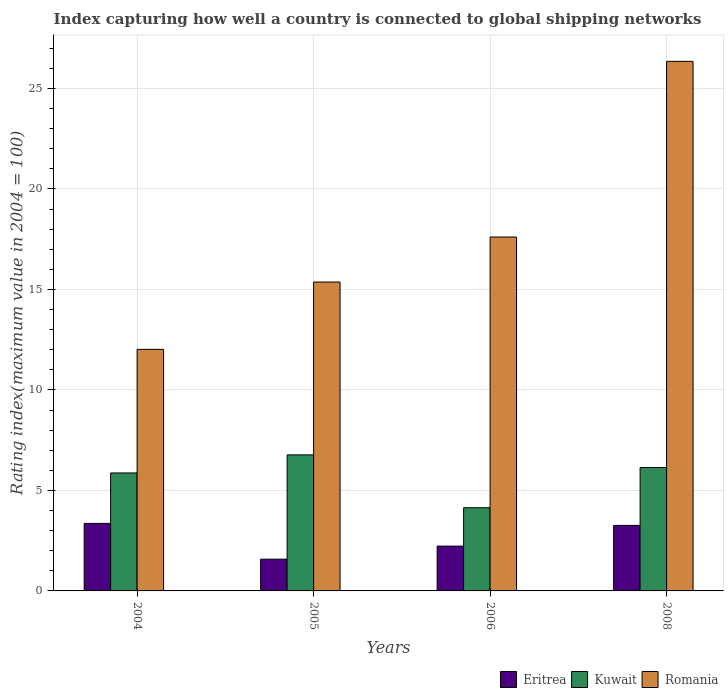How many groups of bars are there?
Provide a succinct answer. 4. Are the number of bars per tick equal to the number of legend labels?
Keep it short and to the point. Yes. How many bars are there on the 4th tick from the left?
Offer a very short reply. 3. What is the label of the 4th group of bars from the left?
Ensure brevity in your answer.  2008. In how many cases, is the number of bars for a given year not equal to the number of legend labels?
Your answer should be compact. 0. What is the rating index in Romania in 2005?
Make the answer very short. 15.37. Across all years, what is the maximum rating index in Romania?
Keep it short and to the point. 26.35. Across all years, what is the minimum rating index in Kuwait?
Offer a terse response. 4.14. What is the total rating index in Romania in the graph?
Keep it short and to the point. 71.35. What is the difference between the rating index in Kuwait in 2006 and that in 2008?
Provide a short and direct response. -2. What is the difference between the rating index in Romania in 2005 and the rating index in Eritrea in 2006?
Ensure brevity in your answer.  13.14. What is the average rating index in Eritrea per year?
Ensure brevity in your answer.  2.61. In the year 2005, what is the difference between the rating index in Kuwait and rating index in Eritrea?
Offer a very short reply. 5.19. In how many years, is the rating index in Kuwait greater than 22?
Provide a succinct answer. 0. What is the ratio of the rating index in Romania in 2004 to that in 2005?
Offer a very short reply. 0.78. Is the difference between the rating index in Kuwait in 2005 and 2008 greater than the difference between the rating index in Eritrea in 2005 and 2008?
Offer a very short reply. Yes. What is the difference between the highest and the second highest rating index in Romania?
Keep it short and to the point. 8.74. What is the difference between the highest and the lowest rating index in Eritrea?
Ensure brevity in your answer.  1.78. What does the 2nd bar from the left in 2006 represents?
Your answer should be compact. Kuwait. What does the 1st bar from the right in 2004 represents?
Provide a succinct answer. Romania. How many bars are there?
Give a very brief answer. 12. How many years are there in the graph?
Provide a short and direct response. 4. What is the difference between two consecutive major ticks on the Y-axis?
Give a very brief answer. 5. Are the values on the major ticks of Y-axis written in scientific E-notation?
Offer a terse response. No. Does the graph contain grids?
Ensure brevity in your answer.  Yes. Where does the legend appear in the graph?
Give a very brief answer. Bottom right. What is the title of the graph?
Your answer should be very brief. Index capturing how well a country is connected to global shipping networks. Does "Small states" appear as one of the legend labels in the graph?
Offer a very short reply. No. What is the label or title of the X-axis?
Provide a succinct answer. Years. What is the label or title of the Y-axis?
Your answer should be very brief. Rating index(maximum value in 2004 = 100). What is the Rating index(maximum value in 2004 = 100) of Eritrea in 2004?
Provide a short and direct response. 3.36. What is the Rating index(maximum value in 2004 = 100) in Kuwait in 2004?
Provide a succinct answer. 5.87. What is the Rating index(maximum value in 2004 = 100) of Romania in 2004?
Provide a short and direct response. 12.02. What is the Rating index(maximum value in 2004 = 100) in Eritrea in 2005?
Offer a terse response. 1.58. What is the Rating index(maximum value in 2004 = 100) in Kuwait in 2005?
Provide a succinct answer. 6.77. What is the Rating index(maximum value in 2004 = 100) in Romania in 2005?
Your response must be concise. 15.37. What is the Rating index(maximum value in 2004 = 100) of Eritrea in 2006?
Your response must be concise. 2.23. What is the Rating index(maximum value in 2004 = 100) in Kuwait in 2006?
Offer a terse response. 4.14. What is the Rating index(maximum value in 2004 = 100) of Romania in 2006?
Make the answer very short. 17.61. What is the Rating index(maximum value in 2004 = 100) of Eritrea in 2008?
Your response must be concise. 3.26. What is the Rating index(maximum value in 2004 = 100) in Kuwait in 2008?
Your answer should be compact. 6.14. What is the Rating index(maximum value in 2004 = 100) of Romania in 2008?
Keep it short and to the point. 26.35. Across all years, what is the maximum Rating index(maximum value in 2004 = 100) in Eritrea?
Make the answer very short. 3.36. Across all years, what is the maximum Rating index(maximum value in 2004 = 100) of Kuwait?
Your answer should be compact. 6.77. Across all years, what is the maximum Rating index(maximum value in 2004 = 100) in Romania?
Provide a succinct answer. 26.35. Across all years, what is the minimum Rating index(maximum value in 2004 = 100) of Eritrea?
Your response must be concise. 1.58. Across all years, what is the minimum Rating index(maximum value in 2004 = 100) in Kuwait?
Offer a very short reply. 4.14. Across all years, what is the minimum Rating index(maximum value in 2004 = 100) of Romania?
Your answer should be very brief. 12.02. What is the total Rating index(maximum value in 2004 = 100) of Eritrea in the graph?
Your answer should be compact. 10.43. What is the total Rating index(maximum value in 2004 = 100) of Kuwait in the graph?
Offer a terse response. 22.92. What is the total Rating index(maximum value in 2004 = 100) of Romania in the graph?
Ensure brevity in your answer.  71.35. What is the difference between the Rating index(maximum value in 2004 = 100) in Eritrea in 2004 and that in 2005?
Keep it short and to the point. 1.78. What is the difference between the Rating index(maximum value in 2004 = 100) of Romania in 2004 and that in 2005?
Your answer should be compact. -3.35. What is the difference between the Rating index(maximum value in 2004 = 100) in Eritrea in 2004 and that in 2006?
Ensure brevity in your answer.  1.13. What is the difference between the Rating index(maximum value in 2004 = 100) in Kuwait in 2004 and that in 2006?
Your answer should be very brief. 1.73. What is the difference between the Rating index(maximum value in 2004 = 100) of Romania in 2004 and that in 2006?
Your response must be concise. -5.59. What is the difference between the Rating index(maximum value in 2004 = 100) in Eritrea in 2004 and that in 2008?
Your answer should be compact. 0.1. What is the difference between the Rating index(maximum value in 2004 = 100) in Kuwait in 2004 and that in 2008?
Keep it short and to the point. -0.27. What is the difference between the Rating index(maximum value in 2004 = 100) in Romania in 2004 and that in 2008?
Offer a very short reply. -14.33. What is the difference between the Rating index(maximum value in 2004 = 100) in Eritrea in 2005 and that in 2006?
Provide a short and direct response. -0.65. What is the difference between the Rating index(maximum value in 2004 = 100) in Kuwait in 2005 and that in 2006?
Offer a very short reply. 2.63. What is the difference between the Rating index(maximum value in 2004 = 100) in Romania in 2005 and that in 2006?
Offer a very short reply. -2.24. What is the difference between the Rating index(maximum value in 2004 = 100) in Eritrea in 2005 and that in 2008?
Give a very brief answer. -1.68. What is the difference between the Rating index(maximum value in 2004 = 100) in Kuwait in 2005 and that in 2008?
Make the answer very short. 0.63. What is the difference between the Rating index(maximum value in 2004 = 100) in Romania in 2005 and that in 2008?
Offer a very short reply. -10.98. What is the difference between the Rating index(maximum value in 2004 = 100) of Eritrea in 2006 and that in 2008?
Make the answer very short. -1.03. What is the difference between the Rating index(maximum value in 2004 = 100) of Romania in 2006 and that in 2008?
Give a very brief answer. -8.74. What is the difference between the Rating index(maximum value in 2004 = 100) in Eritrea in 2004 and the Rating index(maximum value in 2004 = 100) in Kuwait in 2005?
Offer a very short reply. -3.41. What is the difference between the Rating index(maximum value in 2004 = 100) in Eritrea in 2004 and the Rating index(maximum value in 2004 = 100) in Romania in 2005?
Offer a terse response. -12.01. What is the difference between the Rating index(maximum value in 2004 = 100) of Kuwait in 2004 and the Rating index(maximum value in 2004 = 100) of Romania in 2005?
Your answer should be very brief. -9.5. What is the difference between the Rating index(maximum value in 2004 = 100) of Eritrea in 2004 and the Rating index(maximum value in 2004 = 100) of Kuwait in 2006?
Keep it short and to the point. -0.78. What is the difference between the Rating index(maximum value in 2004 = 100) of Eritrea in 2004 and the Rating index(maximum value in 2004 = 100) of Romania in 2006?
Ensure brevity in your answer.  -14.25. What is the difference between the Rating index(maximum value in 2004 = 100) of Kuwait in 2004 and the Rating index(maximum value in 2004 = 100) of Romania in 2006?
Provide a succinct answer. -11.74. What is the difference between the Rating index(maximum value in 2004 = 100) of Eritrea in 2004 and the Rating index(maximum value in 2004 = 100) of Kuwait in 2008?
Offer a very short reply. -2.78. What is the difference between the Rating index(maximum value in 2004 = 100) in Eritrea in 2004 and the Rating index(maximum value in 2004 = 100) in Romania in 2008?
Provide a short and direct response. -22.99. What is the difference between the Rating index(maximum value in 2004 = 100) in Kuwait in 2004 and the Rating index(maximum value in 2004 = 100) in Romania in 2008?
Your answer should be compact. -20.48. What is the difference between the Rating index(maximum value in 2004 = 100) in Eritrea in 2005 and the Rating index(maximum value in 2004 = 100) in Kuwait in 2006?
Offer a terse response. -2.56. What is the difference between the Rating index(maximum value in 2004 = 100) in Eritrea in 2005 and the Rating index(maximum value in 2004 = 100) in Romania in 2006?
Offer a very short reply. -16.03. What is the difference between the Rating index(maximum value in 2004 = 100) of Kuwait in 2005 and the Rating index(maximum value in 2004 = 100) of Romania in 2006?
Offer a terse response. -10.84. What is the difference between the Rating index(maximum value in 2004 = 100) of Eritrea in 2005 and the Rating index(maximum value in 2004 = 100) of Kuwait in 2008?
Offer a terse response. -4.56. What is the difference between the Rating index(maximum value in 2004 = 100) of Eritrea in 2005 and the Rating index(maximum value in 2004 = 100) of Romania in 2008?
Your response must be concise. -24.77. What is the difference between the Rating index(maximum value in 2004 = 100) of Kuwait in 2005 and the Rating index(maximum value in 2004 = 100) of Romania in 2008?
Your answer should be compact. -19.58. What is the difference between the Rating index(maximum value in 2004 = 100) of Eritrea in 2006 and the Rating index(maximum value in 2004 = 100) of Kuwait in 2008?
Your answer should be very brief. -3.91. What is the difference between the Rating index(maximum value in 2004 = 100) in Eritrea in 2006 and the Rating index(maximum value in 2004 = 100) in Romania in 2008?
Offer a very short reply. -24.12. What is the difference between the Rating index(maximum value in 2004 = 100) in Kuwait in 2006 and the Rating index(maximum value in 2004 = 100) in Romania in 2008?
Keep it short and to the point. -22.21. What is the average Rating index(maximum value in 2004 = 100) of Eritrea per year?
Ensure brevity in your answer.  2.61. What is the average Rating index(maximum value in 2004 = 100) in Kuwait per year?
Keep it short and to the point. 5.73. What is the average Rating index(maximum value in 2004 = 100) in Romania per year?
Offer a very short reply. 17.84. In the year 2004, what is the difference between the Rating index(maximum value in 2004 = 100) of Eritrea and Rating index(maximum value in 2004 = 100) of Kuwait?
Your response must be concise. -2.51. In the year 2004, what is the difference between the Rating index(maximum value in 2004 = 100) in Eritrea and Rating index(maximum value in 2004 = 100) in Romania?
Ensure brevity in your answer.  -8.66. In the year 2004, what is the difference between the Rating index(maximum value in 2004 = 100) in Kuwait and Rating index(maximum value in 2004 = 100) in Romania?
Give a very brief answer. -6.15. In the year 2005, what is the difference between the Rating index(maximum value in 2004 = 100) of Eritrea and Rating index(maximum value in 2004 = 100) of Kuwait?
Give a very brief answer. -5.19. In the year 2005, what is the difference between the Rating index(maximum value in 2004 = 100) in Eritrea and Rating index(maximum value in 2004 = 100) in Romania?
Provide a short and direct response. -13.79. In the year 2005, what is the difference between the Rating index(maximum value in 2004 = 100) of Kuwait and Rating index(maximum value in 2004 = 100) of Romania?
Keep it short and to the point. -8.6. In the year 2006, what is the difference between the Rating index(maximum value in 2004 = 100) in Eritrea and Rating index(maximum value in 2004 = 100) in Kuwait?
Keep it short and to the point. -1.91. In the year 2006, what is the difference between the Rating index(maximum value in 2004 = 100) of Eritrea and Rating index(maximum value in 2004 = 100) of Romania?
Offer a very short reply. -15.38. In the year 2006, what is the difference between the Rating index(maximum value in 2004 = 100) of Kuwait and Rating index(maximum value in 2004 = 100) of Romania?
Give a very brief answer. -13.47. In the year 2008, what is the difference between the Rating index(maximum value in 2004 = 100) in Eritrea and Rating index(maximum value in 2004 = 100) in Kuwait?
Your response must be concise. -2.88. In the year 2008, what is the difference between the Rating index(maximum value in 2004 = 100) in Eritrea and Rating index(maximum value in 2004 = 100) in Romania?
Give a very brief answer. -23.09. In the year 2008, what is the difference between the Rating index(maximum value in 2004 = 100) of Kuwait and Rating index(maximum value in 2004 = 100) of Romania?
Keep it short and to the point. -20.21. What is the ratio of the Rating index(maximum value in 2004 = 100) of Eritrea in 2004 to that in 2005?
Provide a short and direct response. 2.13. What is the ratio of the Rating index(maximum value in 2004 = 100) of Kuwait in 2004 to that in 2005?
Offer a terse response. 0.87. What is the ratio of the Rating index(maximum value in 2004 = 100) in Romania in 2004 to that in 2005?
Your answer should be very brief. 0.78. What is the ratio of the Rating index(maximum value in 2004 = 100) of Eritrea in 2004 to that in 2006?
Your answer should be very brief. 1.51. What is the ratio of the Rating index(maximum value in 2004 = 100) in Kuwait in 2004 to that in 2006?
Ensure brevity in your answer.  1.42. What is the ratio of the Rating index(maximum value in 2004 = 100) in Romania in 2004 to that in 2006?
Ensure brevity in your answer.  0.68. What is the ratio of the Rating index(maximum value in 2004 = 100) of Eritrea in 2004 to that in 2008?
Keep it short and to the point. 1.03. What is the ratio of the Rating index(maximum value in 2004 = 100) in Kuwait in 2004 to that in 2008?
Offer a terse response. 0.96. What is the ratio of the Rating index(maximum value in 2004 = 100) in Romania in 2004 to that in 2008?
Give a very brief answer. 0.46. What is the ratio of the Rating index(maximum value in 2004 = 100) of Eritrea in 2005 to that in 2006?
Ensure brevity in your answer.  0.71. What is the ratio of the Rating index(maximum value in 2004 = 100) of Kuwait in 2005 to that in 2006?
Your answer should be compact. 1.64. What is the ratio of the Rating index(maximum value in 2004 = 100) in Romania in 2005 to that in 2006?
Ensure brevity in your answer.  0.87. What is the ratio of the Rating index(maximum value in 2004 = 100) of Eritrea in 2005 to that in 2008?
Ensure brevity in your answer.  0.48. What is the ratio of the Rating index(maximum value in 2004 = 100) in Kuwait in 2005 to that in 2008?
Keep it short and to the point. 1.1. What is the ratio of the Rating index(maximum value in 2004 = 100) in Romania in 2005 to that in 2008?
Offer a very short reply. 0.58. What is the ratio of the Rating index(maximum value in 2004 = 100) of Eritrea in 2006 to that in 2008?
Provide a succinct answer. 0.68. What is the ratio of the Rating index(maximum value in 2004 = 100) in Kuwait in 2006 to that in 2008?
Provide a short and direct response. 0.67. What is the ratio of the Rating index(maximum value in 2004 = 100) in Romania in 2006 to that in 2008?
Make the answer very short. 0.67. What is the difference between the highest and the second highest Rating index(maximum value in 2004 = 100) in Eritrea?
Provide a succinct answer. 0.1. What is the difference between the highest and the second highest Rating index(maximum value in 2004 = 100) in Kuwait?
Ensure brevity in your answer.  0.63. What is the difference between the highest and the second highest Rating index(maximum value in 2004 = 100) in Romania?
Keep it short and to the point. 8.74. What is the difference between the highest and the lowest Rating index(maximum value in 2004 = 100) of Eritrea?
Give a very brief answer. 1.78. What is the difference between the highest and the lowest Rating index(maximum value in 2004 = 100) of Kuwait?
Your response must be concise. 2.63. What is the difference between the highest and the lowest Rating index(maximum value in 2004 = 100) in Romania?
Your answer should be compact. 14.33. 